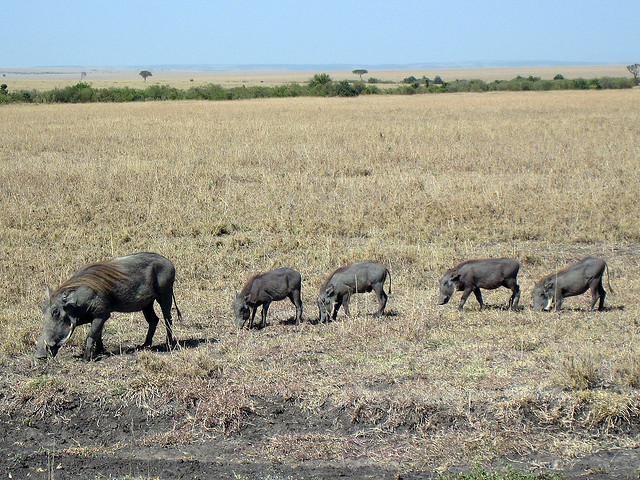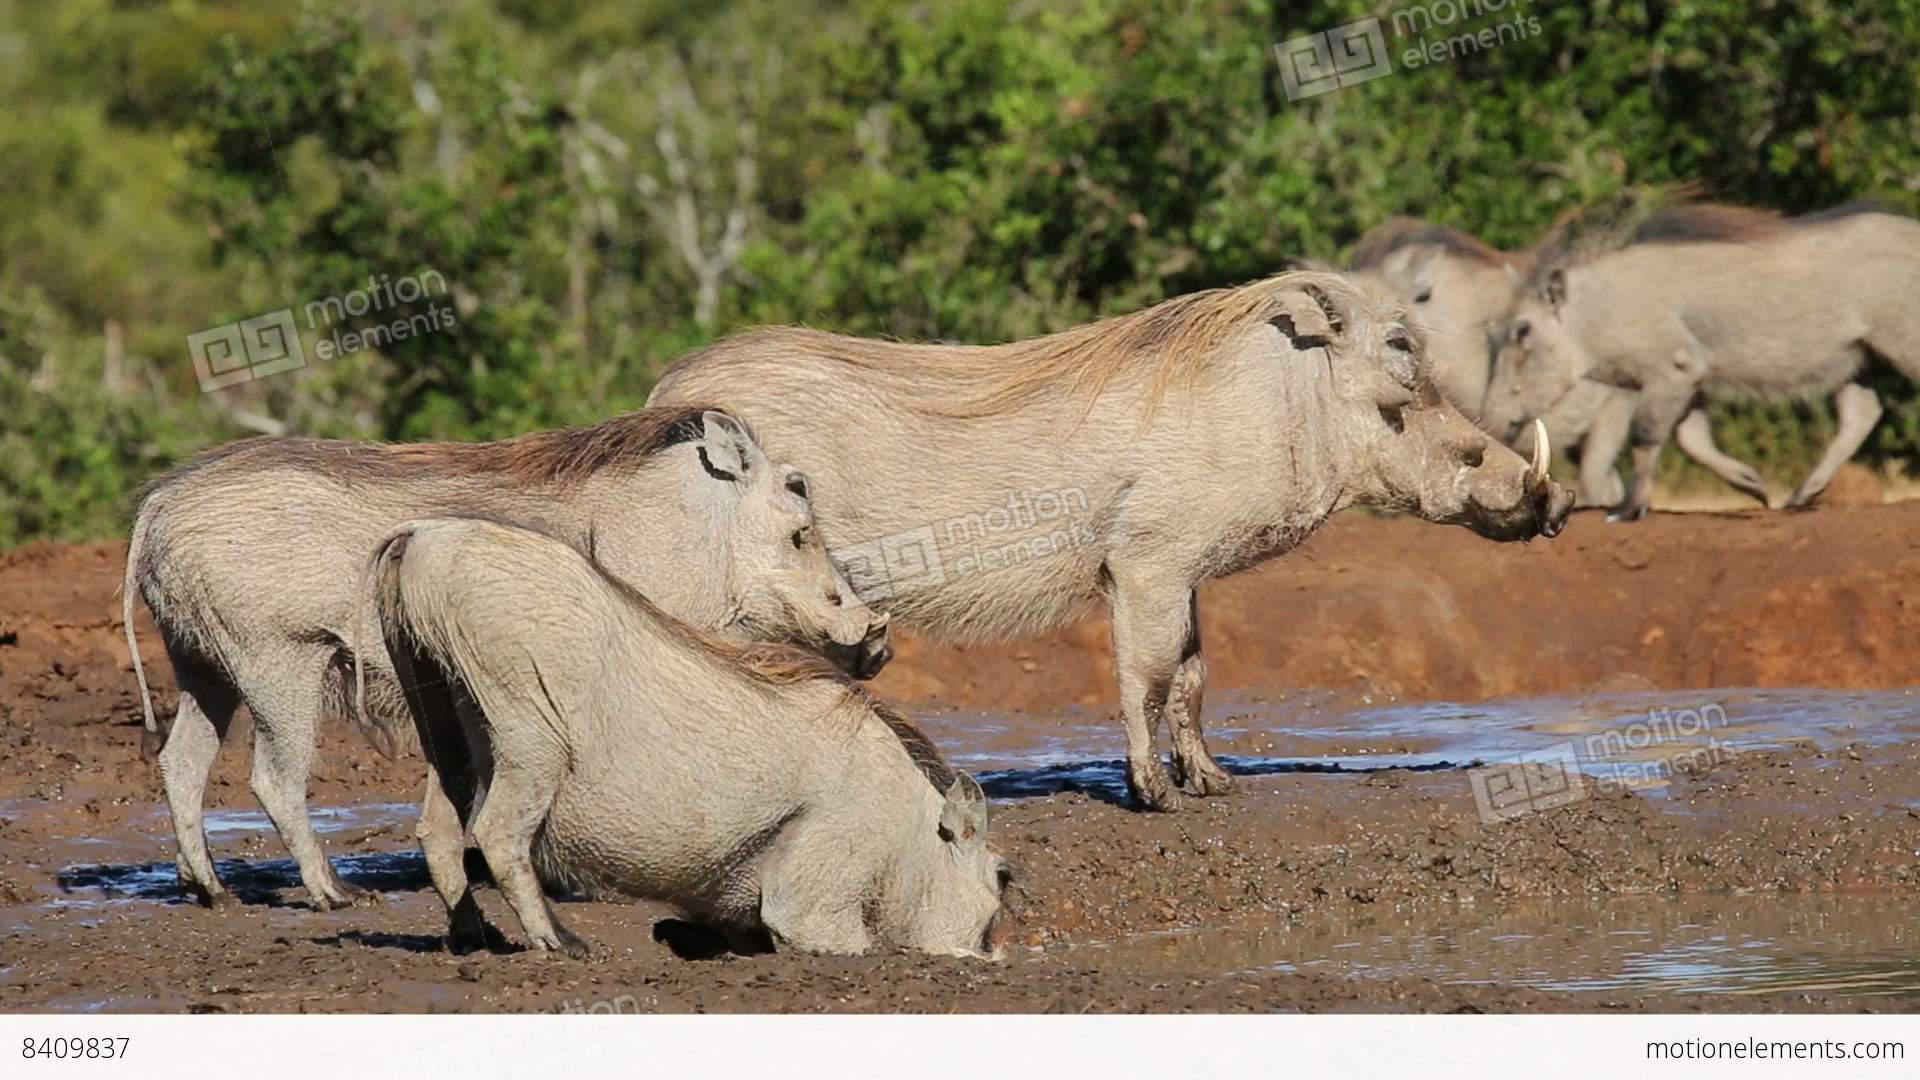The first image is the image on the left, the second image is the image on the right. Given the left and right images, does the statement "There are five warthogs in the left image." hold true? Answer yes or no. Yes. 